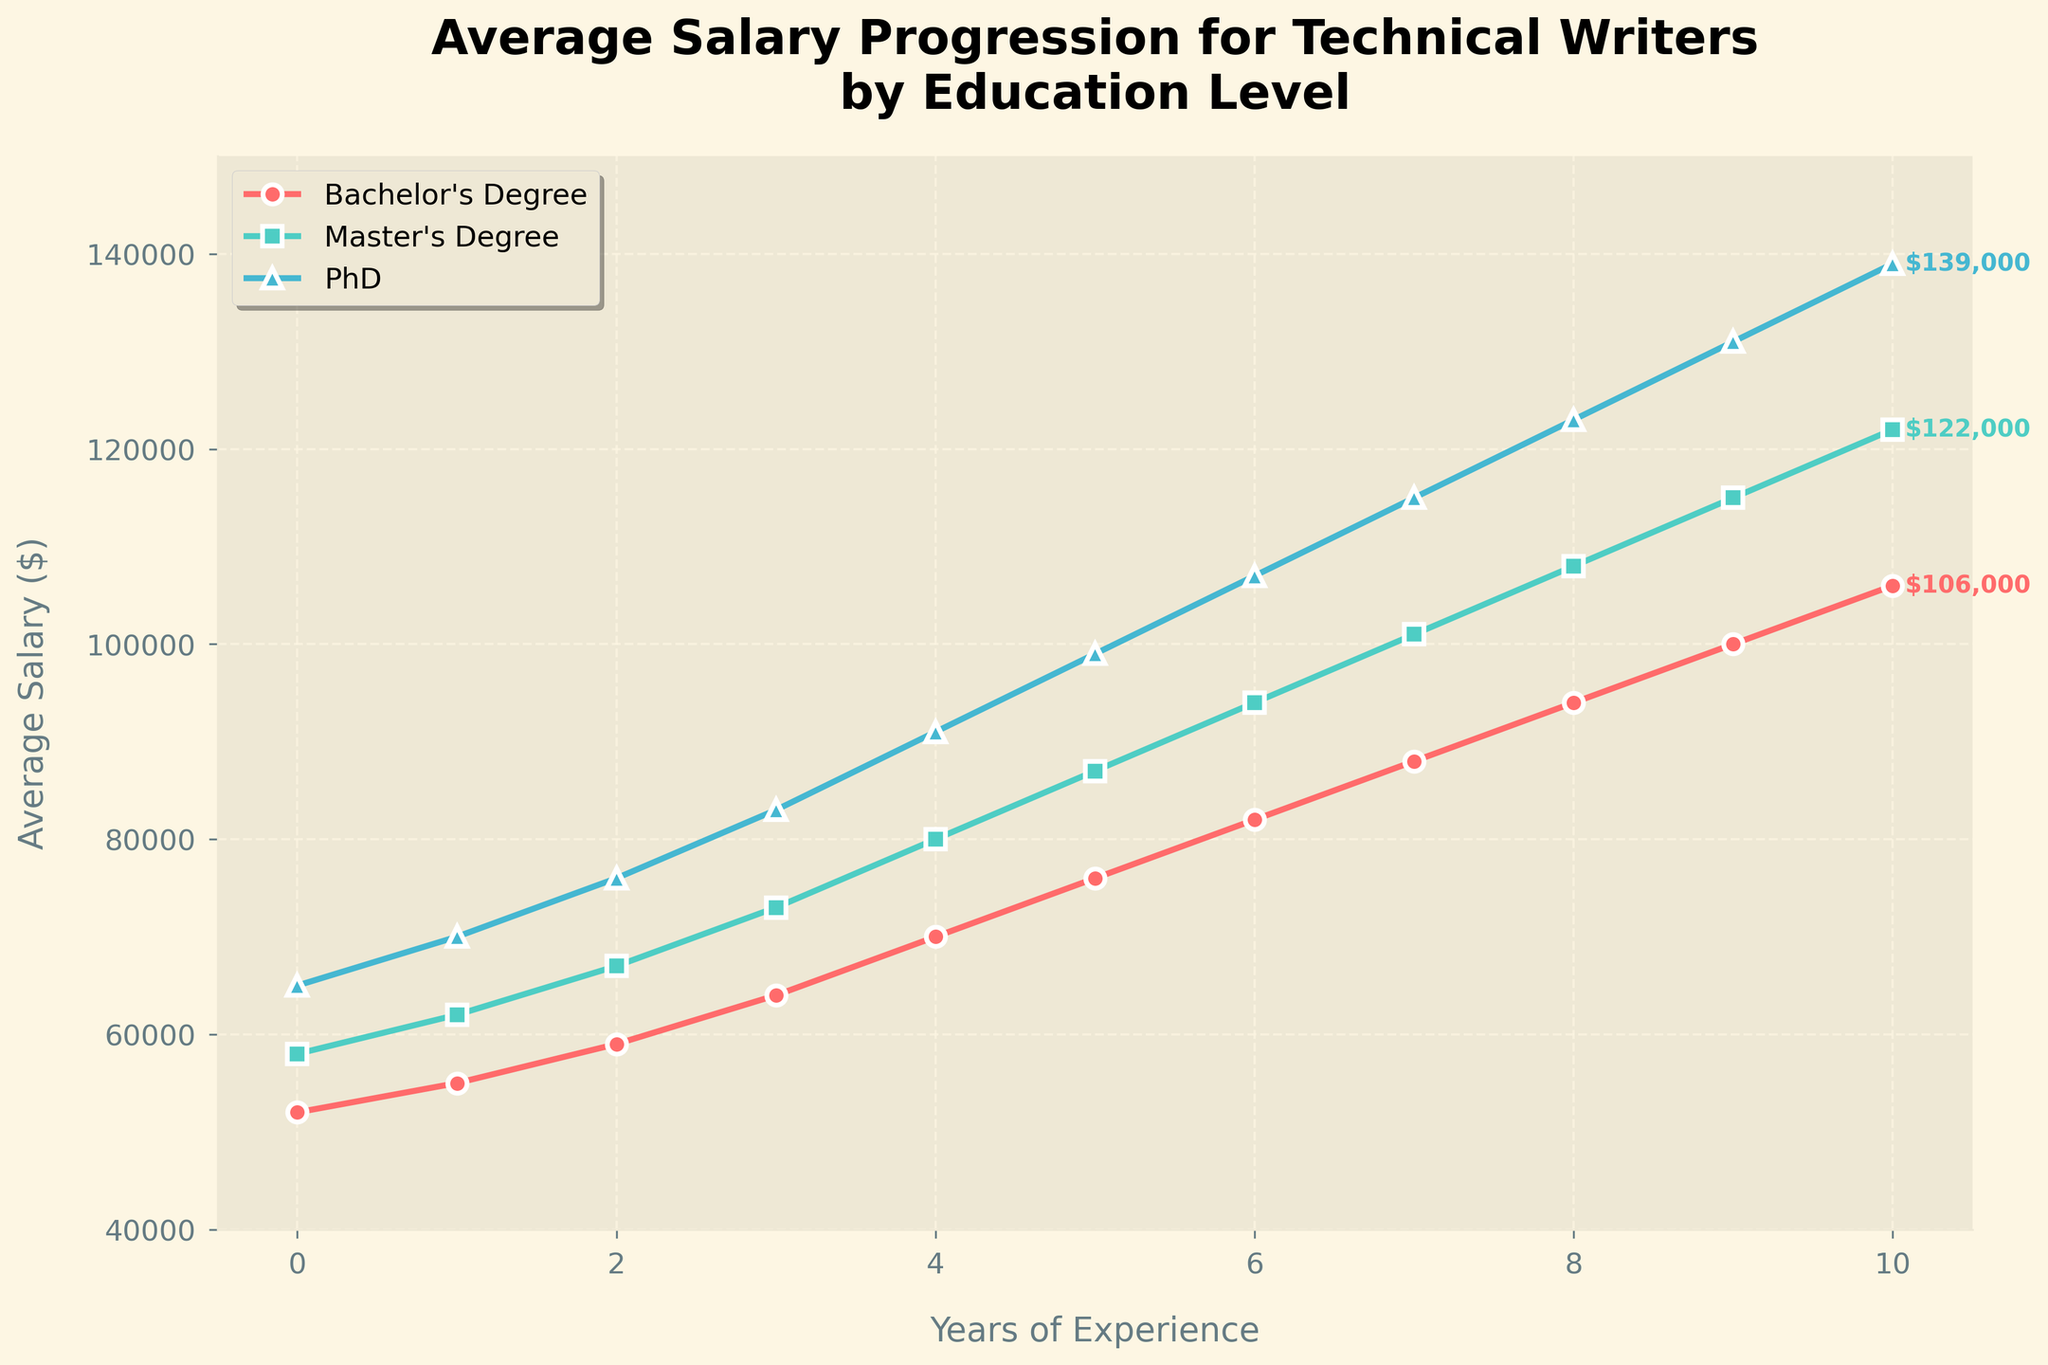Which education level reaches the highest salary at the end of 10 years? Look at the endpoints of each line on the graph and compare the highest values. The PhD line ends at the highest point, indicating it has the highest salary at the end of 10 years.
Answer: PhD How much higher is the salary for a PhD compared to a Bachelor's Degree after 10 years? Look at the salaries for both education levels at the 10-year mark. The Bachelor's Degree salary is $106,000, and the PhD salary is $139,000. Subtract the Bachelor's Degree salary from the PhD salary: $139,000 - $106,000.
Answer: $33,000 Which degree shows the most consistent year-over-year salary increase? Observe the slope of each line. The steepness and consistency of slope indicate consistent increases. The lines for Master's and PhD both show consistent increases, while the Bachelor's line fluctuates more.
Answer: Master's Degree and PhD At what year does the salary for a Bachelor's Degree reach $82,000? Trace the Bachelor's Degree line until it intersects the $82,000 mark on the y-axis. This occurs at the 6-year mark.
Answer: Year 6 How does the average salary progression compare between Master’s Degree and Bachelor's Degree in the first two years? Compare the points at year 0, 1, and 2 for both degrees. Initially, there's a difference, and it increases slightly each year. Specifically: 
- Year 0: Bachelor's is $52,000, Master's is $58,000 (difference $6,000)
- Year 1: Bachelor's is $55,000, Master's is $62,000 (difference $7,000)
- Year 2: Bachelor's is $59,000, Master's is $67,000 (difference $8,000)
The gap widens each year.
Answer: Master's Degree shows a greater increase each year Which education level has the steepest increase in salary during the last 3 years (from year 7 to year 10)? Compare the slopes of the lines between year 7 and year 10. 
- Bachelor's increases from $88,000 to $106,000 (increase of $18,000)
- Master's increases from $101,000 to $122,000 (increase of $21,000)
- PhD increases from $115,000 to $139,000 (increase of $24,000)
The PhD line has the steepest increase.
Answer: PhD What is the difference in salary between Master's Degree and PhD at year 5? Look at the salary values at year 5 for both degrees. Master's Degree salary is $87,000, and PhD salary is $99,000. Subtract the Master's salary from the PhD salary: $99,000 - $87,000.
Answer: $12,000 How does the salary progression for technical writers with a Bachelor's Degree compare visually in terms of color and markers with the progression for a Master's Degree? The Bachelor's Degree progression is depicted with a red line and circular markers. The Master's Degree progression is depicted with a green line and square markers.
Answer: Red circles vs. Green squares Which education level's salary surpasses $100,000 the earliest? Identify the point where each line crosses the $100,000 mark on the y-axis:
- Bachelor's Degree: at year 9
- Master's Degree: at year 7
- PhD: at year 5
The PhD's salary surpasses this threshold the earliest.
Answer: PhD 